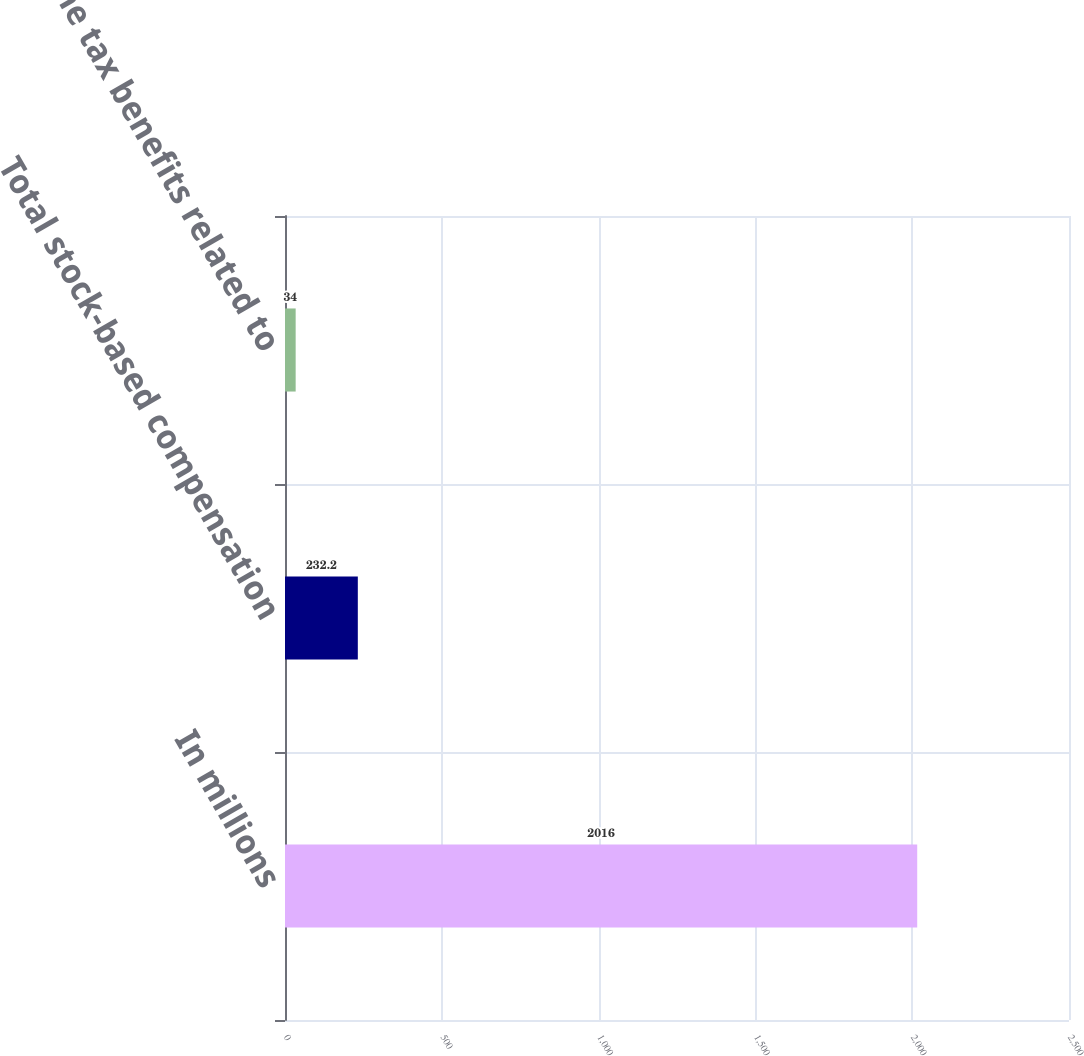Convert chart to OTSL. <chart><loc_0><loc_0><loc_500><loc_500><bar_chart><fcel>In millions<fcel>Total stock-based compensation<fcel>Income tax benefits related to<nl><fcel>2016<fcel>232.2<fcel>34<nl></chart> 